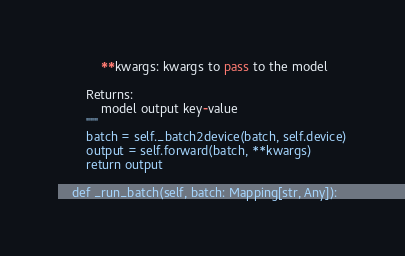Convert code to text. <code><loc_0><loc_0><loc_500><loc_500><_Python_>            **kwargs: kwargs to pass to the model

        Returns:
            model output key-value
        """
        batch = self._batch2device(batch, self.device)
        output = self.forward(batch, **kwargs)
        return output

    def _run_batch(self, batch: Mapping[str, Any]):</code> 